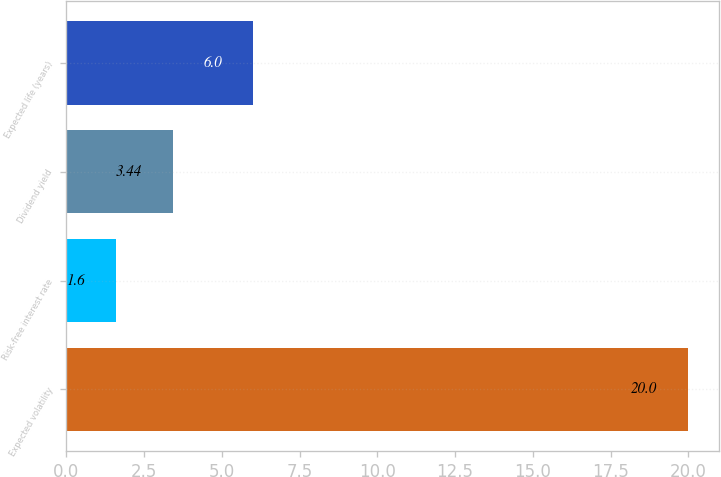Convert chart to OTSL. <chart><loc_0><loc_0><loc_500><loc_500><bar_chart><fcel>Expected volatility<fcel>Risk-free interest rate<fcel>Dividend yield<fcel>Expected life (years)<nl><fcel>20<fcel>1.6<fcel>3.44<fcel>6<nl></chart> 